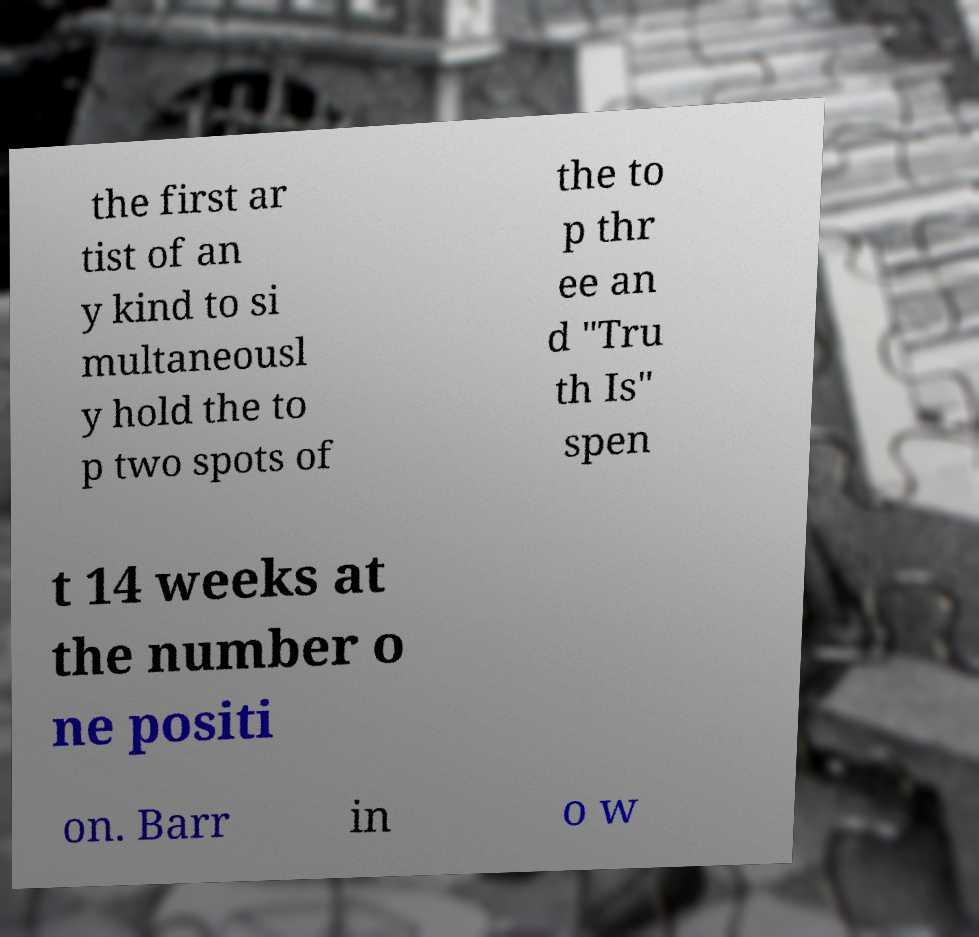For documentation purposes, I need the text within this image transcribed. Could you provide that? the first ar tist of an y kind to si multaneousl y hold the to p two spots of the to p thr ee an d "Tru th Is" spen t 14 weeks at the number o ne positi on. Barr in o w 